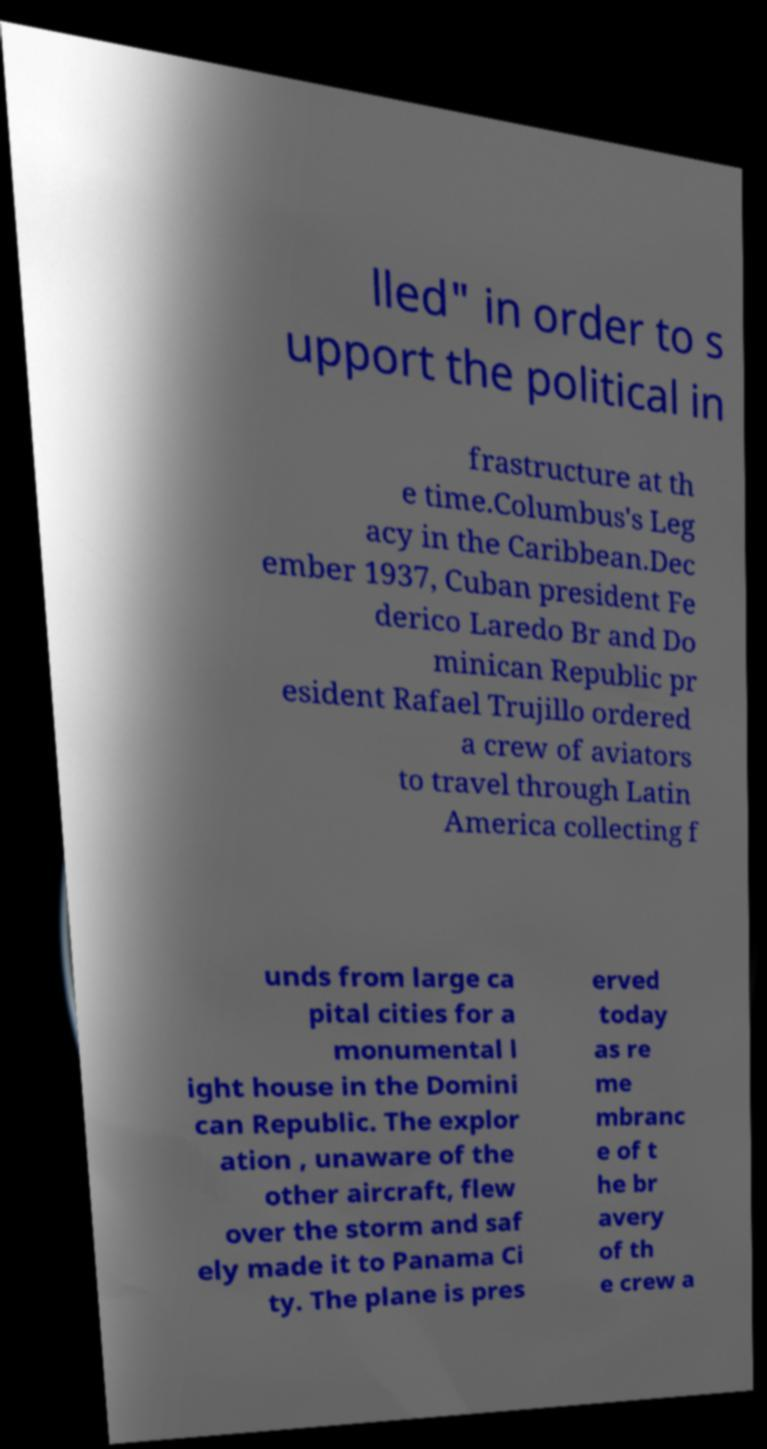Can you accurately transcribe the text from the provided image for me? lled" in order to s upport the political in frastructure at th e time.Columbus's Leg acy in the Caribbean.Dec ember 1937, Cuban president Fe derico Laredo Br and Do minican Republic pr esident Rafael Trujillo ordered a crew of aviators to travel through Latin America collecting f unds from large ca pital cities for a monumental l ight house in the Domini can Republic. The explor ation , unaware of the other aircraft, flew over the storm and saf ely made it to Panama Ci ty. The plane is pres erved today as re me mbranc e of t he br avery of th e crew a 